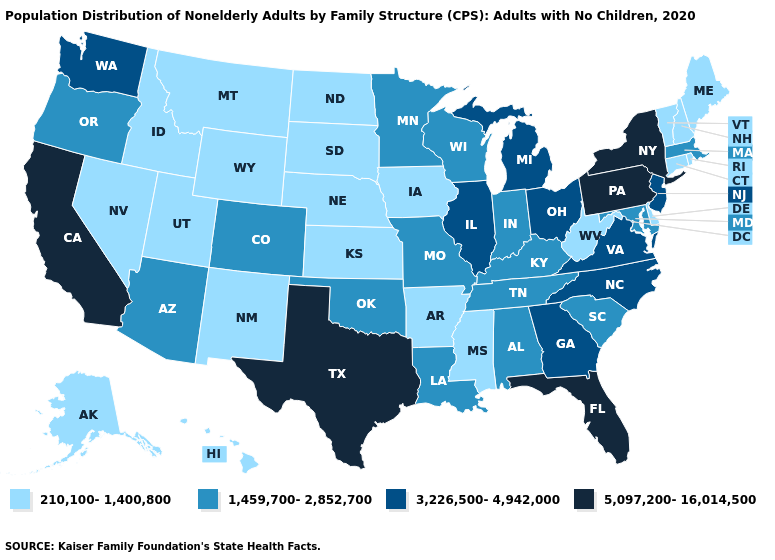Among the states that border New Hampshire , does Maine have the highest value?
Concise answer only. No. What is the highest value in states that border North Dakota?
Quick response, please. 1,459,700-2,852,700. What is the highest value in the South ?
Quick response, please. 5,097,200-16,014,500. Does Wisconsin have a lower value than Virginia?
Answer briefly. Yes. What is the lowest value in the MidWest?
Keep it brief. 210,100-1,400,800. What is the value of California?
Concise answer only. 5,097,200-16,014,500. Which states hav the highest value in the Northeast?
Write a very short answer. New York, Pennsylvania. Which states have the lowest value in the Northeast?
Keep it brief. Connecticut, Maine, New Hampshire, Rhode Island, Vermont. Name the states that have a value in the range 210,100-1,400,800?
Concise answer only. Alaska, Arkansas, Connecticut, Delaware, Hawaii, Idaho, Iowa, Kansas, Maine, Mississippi, Montana, Nebraska, Nevada, New Hampshire, New Mexico, North Dakota, Rhode Island, South Dakota, Utah, Vermont, West Virginia, Wyoming. Does the first symbol in the legend represent the smallest category?
Give a very brief answer. Yes. Name the states that have a value in the range 5,097,200-16,014,500?
Keep it brief. California, Florida, New York, Pennsylvania, Texas. What is the highest value in the USA?
Quick response, please. 5,097,200-16,014,500. What is the highest value in the USA?
Keep it brief. 5,097,200-16,014,500. Which states hav the highest value in the West?
Short answer required. California. Among the states that border Kentucky , does Indiana have the highest value?
Be succinct. No. 